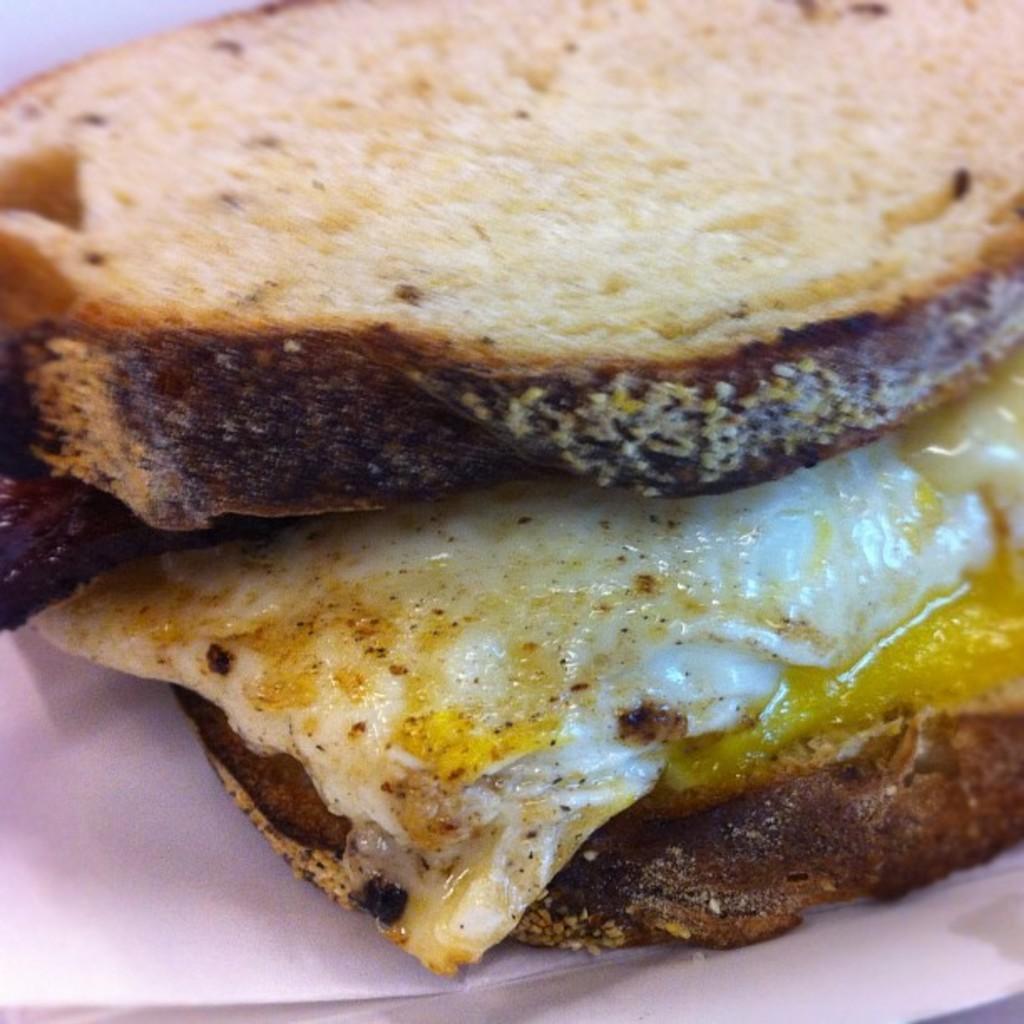Could you give a brief overview of what you see in this image? Here in this picture we can see an omelet present in between two slices of bread, which are present on a plate. 